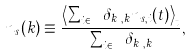Convert formula to latex. <formula><loc_0><loc_0><loc_500><loc_500>n _ { s } ( k ) \equiv \frac { \left \langle \sum _ { i \in { \mathbb { V } } } \delta _ { k _ { i } , k } n _ { s , i } ( t ) \right \rangle _ { t } } { \sum _ { i \in { \mathbb { V } } } \delta _ { k _ { i } , k } } ,</formula> 